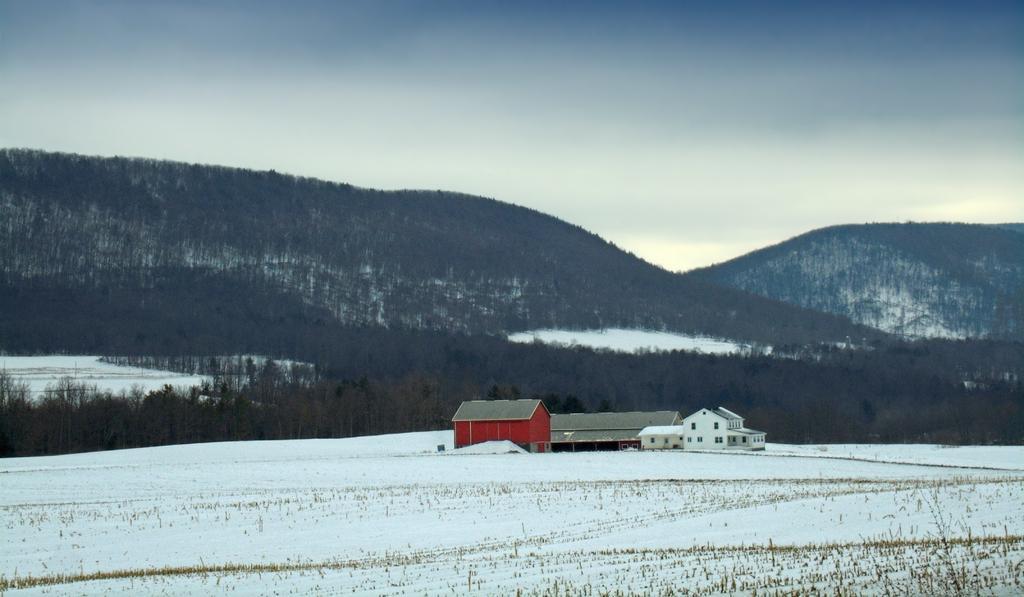Describe this image in one or two sentences. In the foreground of this image, there is snow and the grass. In the middle, there are few buildings. In the background, there are trees, mountains and the sky. 